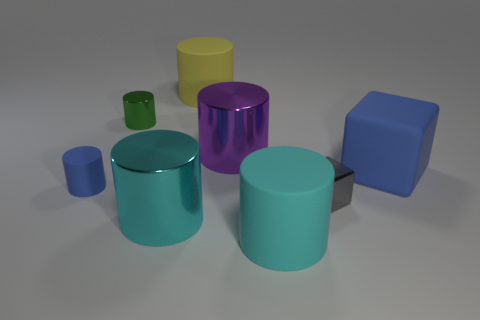What is the size of the cyan metal cylinder?
Give a very brief answer. Large. Is the color of the tiny cylinder that is behind the blue matte cube the same as the rubber block?
Provide a short and direct response. No. Are there any other things that are the same shape as the gray metal thing?
Provide a short and direct response. Yes. Is there a blue matte cylinder that is in front of the tiny metal thing to the left of the large cyan matte object?
Keep it short and to the point. Yes. Are there fewer small gray objects that are behind the green metallic cylinder than big purple shiny cylinders that are in front of the tiny blue thing?
Your answer should be very brief. No. There is a rubber object on the right side of the cyan cylinder on the right side of the large metallic cylinder that is behind the cyan metallic cylinder; what is its size?
Keep it short and to the point. Large. There is a object left of the green metallic object; is it the same size as the small block?
Offer a terse response. Yes. How many other things are the same material as the tiny green thing?
Keep it short and to the point. 3. Are there more large green metallic objects than small green shiny cylinders?
Provide a short and direct response. No. What material is the blue object to the left of the blue matte thing on the right side of the cyan cylinder right of the big yellow cylinder made of?
Make the answer very short. Rubber. 